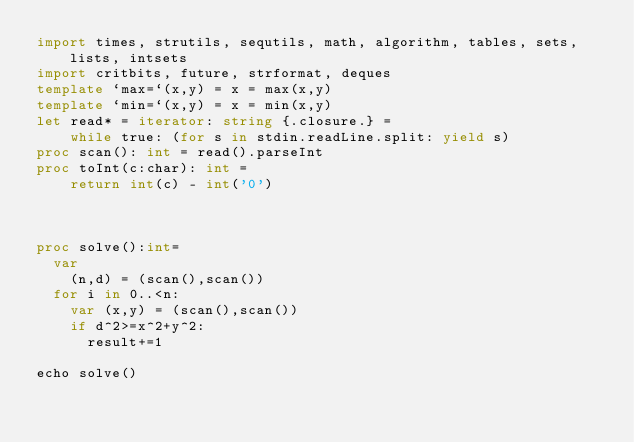<code> <loc_0><loc_0><loc_500><loc_500><_Nim_>import times, strutils, sequtils, math, algorithm, tables, sets, lists, intsets
import critbits, future, strformat, deques
template `max=`(x,y) = x = max(x,y)
template `min=`(x,y) = x = min(x,y)
let read* = iterator: string {.closure.} =
    while true: (for s in stdin.readLine.split: yield s)
proc scan(): int = read().parseInt
proc toInt(c:char): int =
    return int(c) - int('0')



proc solve():int=
  var 
    (n,d) = (scan(),scan())
  for i in 0..<n:
    var (x,y) = (scan(),scan())
    if d^2>=x^2+y^2:
      result+=1

echo solve()</code> 